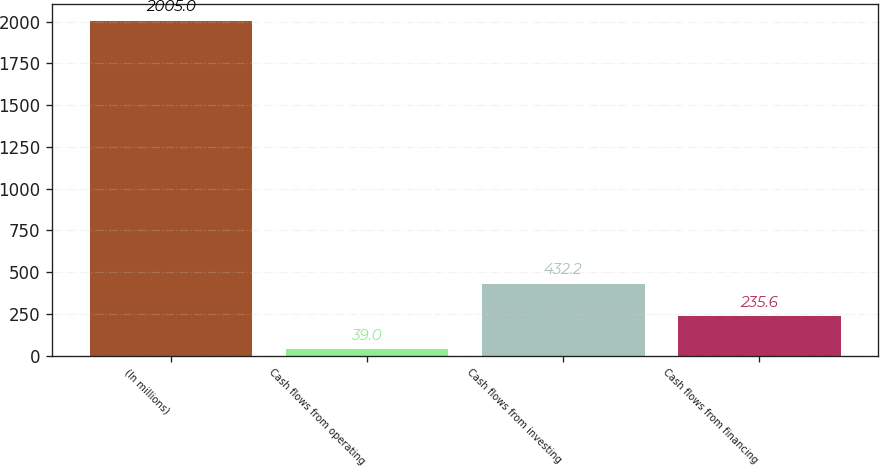Convert chart. <chart><loc_0><loc_0><loc_500><loc_500><bar_chart><fcel>(In millions)<fcel>Cash flows from operating<fcel>Cash flows from investing<fcel>Cash flows from financing<nl><fcel>2005<fcel>39<fcel>432.2<fcel>235.6<nl></chart> 